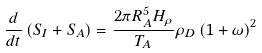Convert formula to latex. <formula><loc_0><loc_0><loc_500><loc_500>\frac { d } { d t } \left ( S _ { I } + S _ { A } \right ) = \frac { 2 \pi R _ { A } ^ { 5 } H _ { \rho } } { T _ { A } } \rho _ { D } \left ( 1 + \omega \right ) ^ { 2 }</formula> 